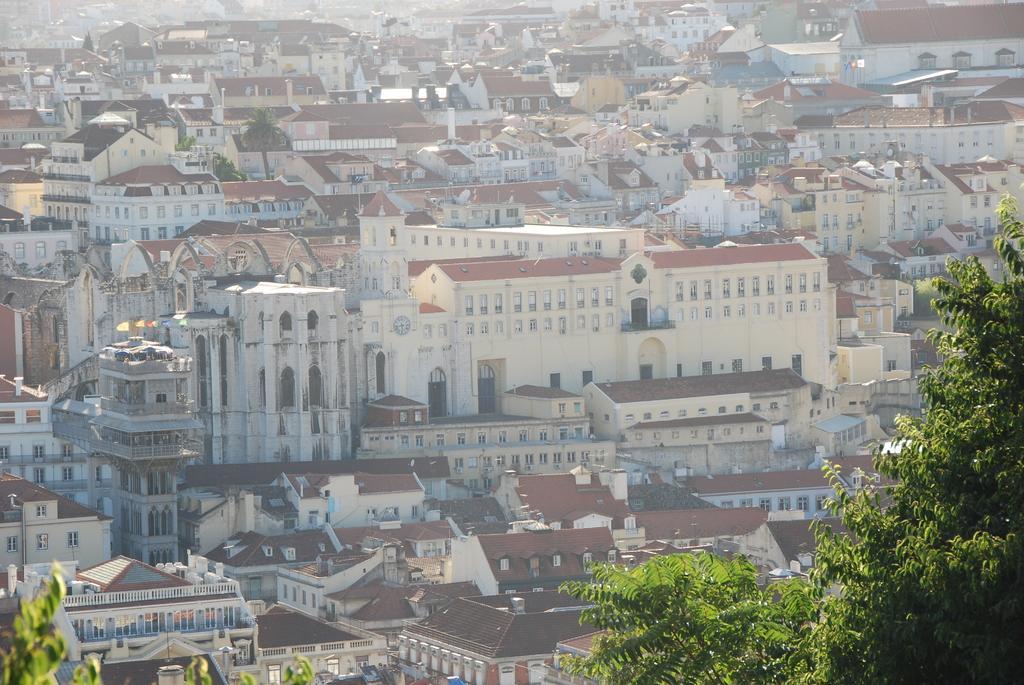Please provide a concise description of this image. In this image I can see houses and building and trees visible at the bottom. 